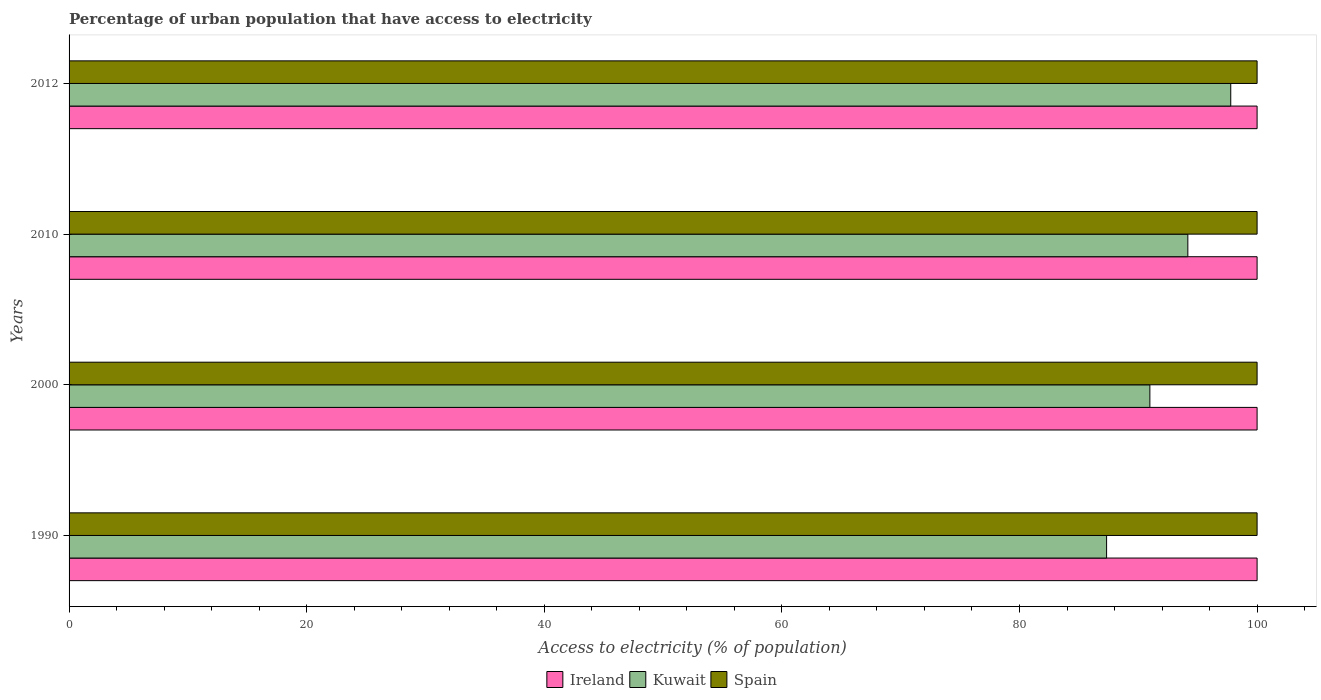How many bars are there on the 3rd tick from the top?
Provide a succinct answer. 3. What is the label of the 3rd group of bars from the top?
Offer a terse response. 2000. In how many cases, is the number of bars for a given year not equal to the number of legend labels?
Your response must be concise. 0. What is the percentage of urban population that have access to electricity in Spain in 2012?
Provide a succinct answer. 100. Across all years, what is the maximum percentage of urban population that have access to electricity in Ireland?
Provide a short and direct response. 100. Across all years, what is the minimum percentage of urban population that have access to electricity in Ireland?
Offer a terse response. 100. In which year was the percentage of urban population that have access to electricity in Kuwait minimum?
Your response must be concise. 1990. What is the total percentage of urban population that have access to electricity in Spain in the graph?
Your response must be concise. 400. What is the difference between the percentage of urban population that have access to electricity in Ireland in 1990 and the percentage of urban population that have access to electricity in Kuwait in 2012?
Your answer should be compact. 2.22. In the year 1990, what is the difference between the percentage of urban population that have access to electricity in Kuwait and percentage of urban population that have access to electricity in Spain?
Offer a terse response. -12.67. In how many years, is the percentage of urban population that have access to electricity in Ireland greater than 8 %?
Keep it short and to the point. 4. What is the ratio of the percentage of urban population that have access to electricity in Spain in 1990 to that in 2012?
Your answer should be compact. 1. Is the percentage of urban population that have access to electricity in Kuwait in 2010 less than that in 2012?
Your answer should be very brief. Yes. What is the difference between the highest and the second highest percentage of urban population that have access to electricity in Ireland?
Ensure brevity in your answer.  0. What is the difference between the highest and the lowest percentage of urban population that have access to electricity in Ireland?
Your answer should be very brief. 0. In how many years, is the percentage of urban population that have access to electricity in Spain greater than the average percentage of urban population that have access to electricity in Spain taken over all years?
Offer a very short reply. 0. Is the sum of the percentage of urban population that have access to electricity in Spain in 2010 and 2012 greater than the maximum percentage of urban population that have access to electricity in Kuwait across all years?
Your answer should be very brief. Yes. What does the 1st bar from the top in 2000 represents?
Keep it short and to the point. Spain. What does the 2nd bar from the bottom in 2012 represents?
Give a very brief answer. Kuwait. Is it the case that in every year, the sum of the percentage of urban population that have access to electricity in Kuwait and percentage of urban population that have access to electricity in Spain is greater than the percentage of urban population that have access to electricity in Ireland?
Your answer should be very brief. Yes. Are the values on the major ticks of X-axis written in scientific E-notation?
Your response must be concise. No. Does the graph contain any zero values?
Provide a succinct answer. No. Where does the legend appear in the graph?
Offer a terse response. Bottom center. How many legend labels are there?
Provide a succinct answer. 3. How are the legend labels stacked?
Your answer should be very brief. Horizontal. What is the title of the graph?
Keep it short and to the point. Percentage of urban population that have access to electricity. What is the label or title of the X-axis?
Offer a very short reply. Access to electricity (% of population). What is the Access to electricity (% of population) of Ireland in 1990?
Offer a very short reply. 100. What is the Access to electricity (% of population) in Kuwait in 1990?
Offer a very short reply. 87.33. What is the Access to electricity (% of population) of Ireland in 2000?
Provide a succinct answer. 100. What is the Access to electricity (% of population) of Kuwait in 2000?
Provide a succinct answer. 90.98. What is the Access to electricity (% of population) of Spain in 2000?
Offer a very short reply. 100. What is the Access to electricity (% of population) in Ireland in 2010?
Your answer should be very brief. 100. What is the Access to electricity (% of population) of Kuwait in 2010?
Your answer should be compact. 94.17. What is the Access to electricity (% of population) in Kuwait in 2012?
Offer a very short reply. 97.78. What is the Access to electricity (% of population) of Spain in 2012?
Provide a short and direct response. 100. Across all years, what is the maximum Access to electricity (% of population) in Ireland?
Your response must be concise. 100. Across all years, what is the maximum Access to electricity (% of population) of Kuwait?
Provide a short and direct response. 97.78. Across all years, what is the minimum Access to electricity (% of population) in Kuwait?
Provide a short and direct response. 87.33. What is the total Access to electricity (% of population) of Kuwait in the graph?
Provide a succinct answer. 370.26. What is the difference between the Access to electricity (% of population) of Kuwait in 1990 and that in 2000?
Ensure brevity in your answer.  -3.64. What is the difference between the Access to electricity (% of population) of Spain in 1990 and that in 2000?
Ensure brevity in your answer.  0. What is the difference between the Access to electricity (% of population) of Kuwait in 1990 and that in 2010?
Your answer should be compact. -6.84. What is the difference between the Access to electricity (% of population) of Ireland in 1990 and that in 2012?
Your answer should be very brief. 0. What is the difference between the Access to electricity (% of population) in Kuwait in 1990 and that in 2012?
Your answer should be very brief. -10.45. What is the difference between the Access to electricity (% of population) of Spain in 1990 and that in 2012?
Ensure brevity in your answer.  0. What is the difference between the Access to electricity (% of population) in Kuwait in 2000 and that in 2010?
Your answer should be very brief. -3.2. What is the difference between the Access to electricity (% of population) of Ireland in 2000 and that in 2012?
Give a very brief answer. 0. What is the difference between the Access to electricity (% of population) in Kuwait in 2000 and that in 2012?
Your response must be concise. -6.81. What is the difference between the Access to electricity (% of population) of Spain in 2000 and that in 2012?
Your response must be concise. 0. What is the difference between the Access to electricity (% of population) of Kuwait in 2010 and that in 2012?
Offer a terse response. -3.61. What is the difference between the Access to electricity (% of population) in Spain in 2010 and that in 2012?
Your answer should be very brief. 0. What is the difference between the Access to electricity (% of population) in Ireland in 1990 and the Access to electricity (% of population) in Kuwait in 2000?
Make the answer very short. 9.02. What is the difference between the Access to electricity (% of population) of Kuwait in 1990 and the Access to electricity (% of population) of Spain in 2000?
Make the answer very short. -12.67. What is the difference between the Access to electricity (% of population) of Ireland in 1990 and the Access to electricity (% of population) of Kuwait in 2010?
Keep it short and to the point. 5.83. What is the difference between the Access to electricity (% of population) of Kuwait in 1990 and the Access to electricity (% of population) of Spain in 2010?
Give a very brief answer. -12.67. What is the difference between the Access to electricity (% of population) in Ireland in 1990 and the Access to electricity (% of population) in Kuwait in 2012?
Offer a terse response. 2.22. What is the difference between the Access to electricity (% of population) of Ireland in 1990 and the Access to electricity (% of population) of Spain in 2012?
Give a very brief answer. 0. What is the difference between the Access to electricity (% of population) of Kuwait in 1990 and the Access to electricity (% of population) of Spain in 2012?
Keep it short and to the point. -12.67. What is the difference between the Access to electricity (% of population) in Ireland in 2000 and the Access to electricity (% of population) in Kuwait in 2010?
Your answer should be compact. 5.83. What is the difference between the Access to electricity (% of population) in Kuwait in 2000 and the Access to electricity (% of population) in Spain in 2010?
Keep it short and to the point. -9.02. What is the difference between the Access to electricity (% of population) in Ireland in 2000 and the Access to electricity (% of population) in Kuwait in 2012?
Give a very brief answer. 2.22. What is the difference between the Access to electricity (% of population) of Ireland in 2000 and the Access to electricity (% of population) of Spain in 2012?
Provide a short and direct response. 0. What is the difference between the Access to electricity (% of population) in Kuwait in 2000 and the Access to electricity (% of population) in Spain in 2012?
Give a very brief answer. -9.02. What is the difference between the Access to electricity (% of population) in Ireland in 2010 and the Access to electricity (% of population) in Kuwait in 2012?
Provide a succinct answer. 2.22. What is the difference between the Access to electricity (% of population) of Ireland in 2010 and the Access to electricity (% of population) of Spain in 2012?
Give a very brief answer. 0. What is the difference between the Access to electricity (% of population) in Kuwait in 2010 and the Access to electricity (% of population) in Spain in 2012?
Provide a succinct answer. -5.83. What is the average Access to electricity (% of population) in Ireland per year?
Give a very brief answer. 100. What is the average Access to electricity (% of population) of Kuwait per year?
Provide a succinct answer. 92.57. In the year 1990, what is the difference between the Access to electricity (% of population) in Ireland and Access to electricity (% of population) in Kuwait?
Provide a succinct answer. 12.67. In the year 1990, what is the difference between the Access to electricity (% of population) in Ireland and Access to electricity (% of population) in Spain?
Provide a succinct answer. 0. In the year 1990, what is the difference between the Access to electricity (% of population) of Kuwait and Access to electricity (% of population) of Spain?
Provide a short and direct response. -12.67. In the year 2000, what is the difference between the Access to electricity (% of population) of Ireland and Access to electricity (% of population) of Kuwait?
Your answer should be compact. 9.02. In the year 2000, what is the difference between the Access to electricity (% of population) in Ireland and Access to electricity (% of population) in Spain?
Provide a short and direct response. 0. In the year 2000, what is the difference between the Access to electricity (% of population) of Kuwait and Access to electricity (% of population) of Spain?
Ensure brevity in your answer.  -9.02. In the year 2010, what is the difference between the Access to electricity (% of population) of Ireland and Access to electricity (% of population) of Kuwait?
Your answer should be compact. 5.83. In the year 2010, what is the difference between the Access to electricity (% of population) in Ireland and Access to electricity (% of population) in Spain?
Give a very brief answer. 0. In the year 2010, what is the difference between the Access to electricity (% of population) in Kuwait and Access to electricity (% of population) in Spain?
Your answer should be compact. -5.83. In the year 2012, what is the difference between the Access to electricity (% of population) in Ireland and Access to electricity (% of population) in Kuwait?
Provide a succinct answer. 2.22. In the year 2012, what is the difference between the Access to electricity (% of population) in Ireland and Access to electricity (% of population) in Spain?
Ensure brevity in your answer.  0. In the year 2012, what is the difference between the Access to electricity (% of population) in Kuwait and Access to electricity (% of population) in Spain?
Keep it short and to the point. -2.22. What is the ratio of the Access to electricity (% of population) in Kuwait in 1990 to that in 2000?
Make the answer very short. 0.96. What is the ratio of the Access to electricity (% of population) in Spain in 1990 to that in 2000?
Your answer should be compact. 1. What is the ratio of the Access to electricity (% of population) in Ireland in 1990 to that in 2010?
Offer a very short reply. 1. What is the ratio of the Access to electricity (% of population) of Kuwait in 1990 to that in 2010?
Offer a terse response. 0.93. What is the ratio of the Access to electricity (% of population) of Spain in 1990 to that in 2010?
Keep it short and to the point. 1. What is the ratio of the Access to electricity (% of population) of Kuwait in 1990 to that in 2012?
Your answer should be compact. 0.89. What is the ratio of the Access to electricity (% of population) of Spain in 1990 to that in 2012?
Make the answer very short. 1. What is the ratio of the Access to electricity (% of population) in Kuwait in 2000 to that in 2010?
Provide a short and direct response. 0.97. What is the ratio of the Access to electricity (% of population) of Spain in 2000 to that in 2010?
Your answer should be compact. 1. What is the ratio of the Access to electricity (% of population) in Ireland in 2000 to that in 2012?
Provide a short and direct response. 1. What is the ratio of the Access to electricity (% of population) of Kuwait in 2000 to that in 2012?
Provide a succinct answer. 0.93. What is the ratio of the Access to electricity (% of population) in Spain in 2000 to that in 2012?
Provide a short and direct response. 1. What is the ratio of the Access to electricity (% of population) in Ireland in 2010 to that in 2012?
Offer a very short reply. 1. What is the ratio of the Access to electricity (% of population) in Kuwait in 2010 to that in 2012?
Ensure brevity in your answer.  0.96. What is the ratio of the Access to electricity (% of population) in Spain in 2010 to that in 2012?
Your answer should be very brief. 1. What is the difference between the highest and the second highest Access to electricity (% of population) of Kuwait?
Offer a very short reply. 3.61. What is the difference between the highest and the lowest Access to electricity (% of population) of Kuwait?
Ensure brevity in your answer.  10.45. What is the difference between the highest and the lowest Access to electricity (% of population) of Spain?
Provide a short and direct response. 0. 